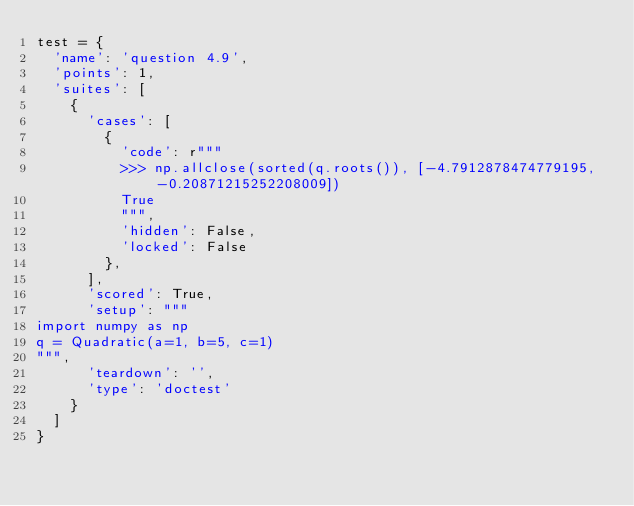<code> <loc_0><loc_0><loc_500><loc_500><_Python_>test = {
  'name': 'question 4.9',
  'points': 1,
  'suites': [
    {
      'cases': [
        {
          'code': r"""
          >>> np.allclose(sorted(q.roots()), [-4.7912878474779195, -0.20871215252208009])
          True
          """,
          'hidden': False,
          'locked': False
        },
      ],
      'scored': True,
      'setup': """
import numpy as np
q = Quadratic(a=1, b=5, c=1)
""",
      'teardown': '',
      'type': 'doctest'
    }
  ]
}
</code> 